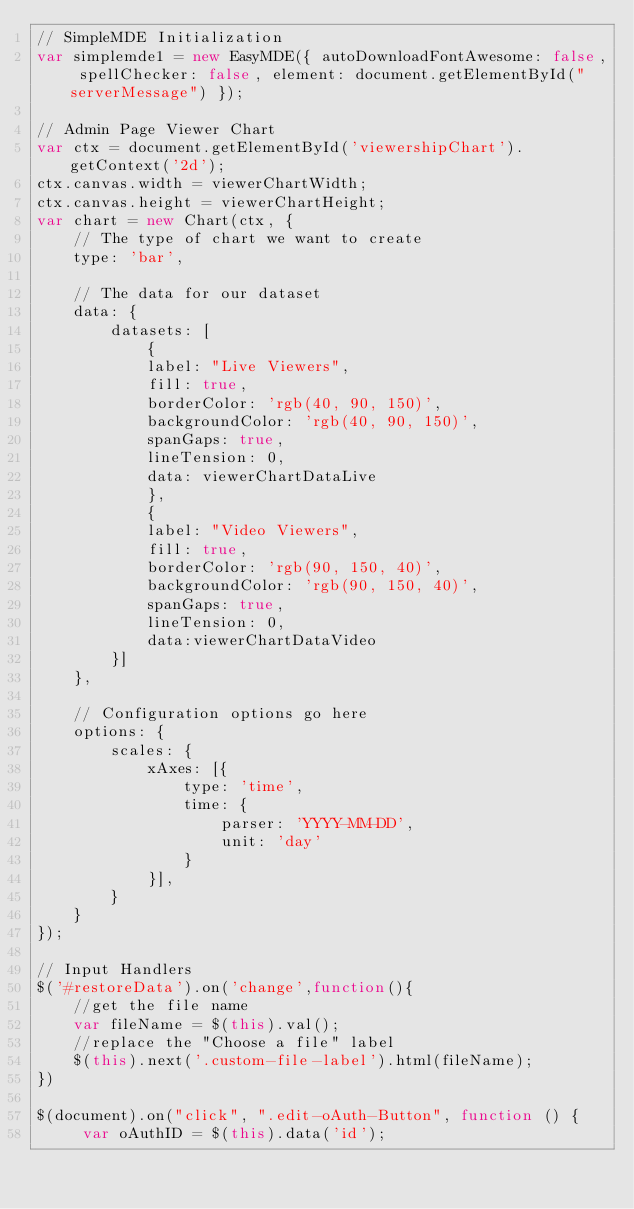<code> <loc_0><loc_0><loc_500><loc_500><_JavaScript_>// SimpleMDE Initialization
var simplemde1 = new EasyMDE({ autoDownloadFontAwesome: false, spellChecker: false, element: document.getElementById("serverMessage") });

// Admin Page Viewer Chart
var ctx = document.getElementById('viewershipChart').getContext('2d');
ctx.canvas.width = viewerChartWidth;
ctx.canvas.height = viewerChartHeight;
var chart = new Chart(ctx, {
    // The type of chart we want to create
    type: 'bar',

    // The data for our dataset
    data: {
        datasets: [
            {
            label: "Live Viewers",
            fill: true,
            borderColor: 'rgb(40, 90, 150)',
            backgroundColor: 'rgb(40, 90, 150)',
            spanGaps: true,
            lineTension: 0,
            data: viewerChartDataLive
            },
            {
            label: "Video Viewers",
            fill: true,
            borderColor: 'rgb(90, 150, 40)',
            backgroundColor: 'rgb(90, 150, 40)',
            spanGaps: true,
            lineTension: 0,
            data:viewerChartDataVideo
        }]
    },

    // Configuration options go here
    options: {
        scales: {
            xAxes: [{
                type: 'time',
                time: {
                    parser: 'YYYY-MM-DD',
                    unit: 'day'
                }
            }],
        }
    }
});

// Input Handlers
$('#restoreData').on('change',function(){
    //get the file name
    var fileName = $(this).val();
    //replace the "Choose a file" label
    $(this).next('.custom-file-label').html(fileName);
})

$(document).on("click", ".edit-oAuth-Button", function () {
     var oAuthID = $(this).data('id');</code> 